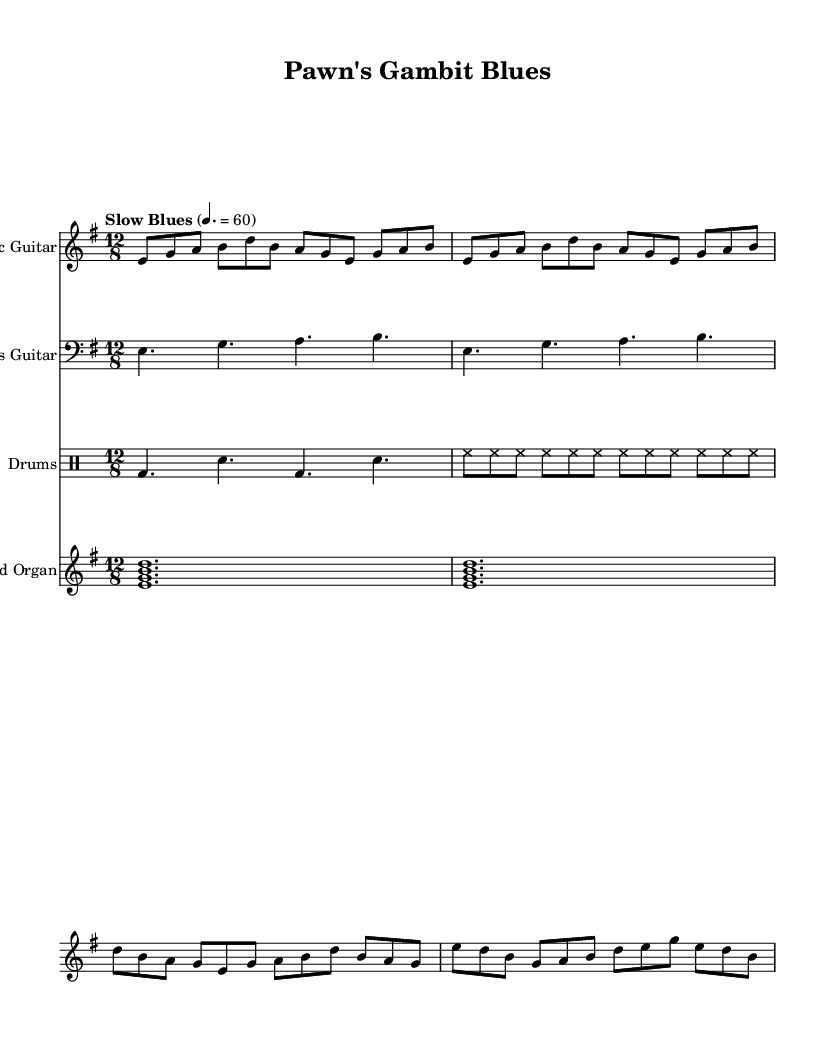What is the key signature of this music? The key signature is E minor, indicated by one sharp (F#). This can be identified by looking for the sharp symbol at the beginning of the staff, which is a common way to denote tonalities.
Answer: E minor What is the time signature? The time signature is 12/8, denoted at the beginning of the score with the numbers stacked vertically. This means there are 12 eighth notes per measure, typical for a shuffle rhythm often found in blues music.
Answer: 12/8 What is the tempo marking? The tempo marking is "Slow Blues," followed by a metronome marking of 60 beats per minute. This indicates how fast the music should be played, specifically within the "blues" style.
Answer: Slow Blues How many measures are in the verse? There are two measures in the verse section as indicated by the notation of notes and the structure of the music; when counting the notes in the verse, you can also observe the repeated phrasing which typically signifies a strong structure commonly found in blues.
Answer: 2 What instruments are featured in this piece? The featured instruments in this piece are Electric Guitar, Bass Guitar, Drums, and Hammond Organ, which are labeled at the beginning of each staff in the score. These instruments together create the characteristic sound of electric blues.
Answer: Electric Guitar, Bass Guitar, Drums, Hammond Organ How does the use of eighth notes in the bass line affect the groove? The eighth notes create a driving rhythm that establishes the groove typical of electric blues, providing a solid foundation for the other instruments. The syncopation between the bass and drums enhances this rhythmic shuffle feel prevalent in blues music.
Answer: Driving rhythm 